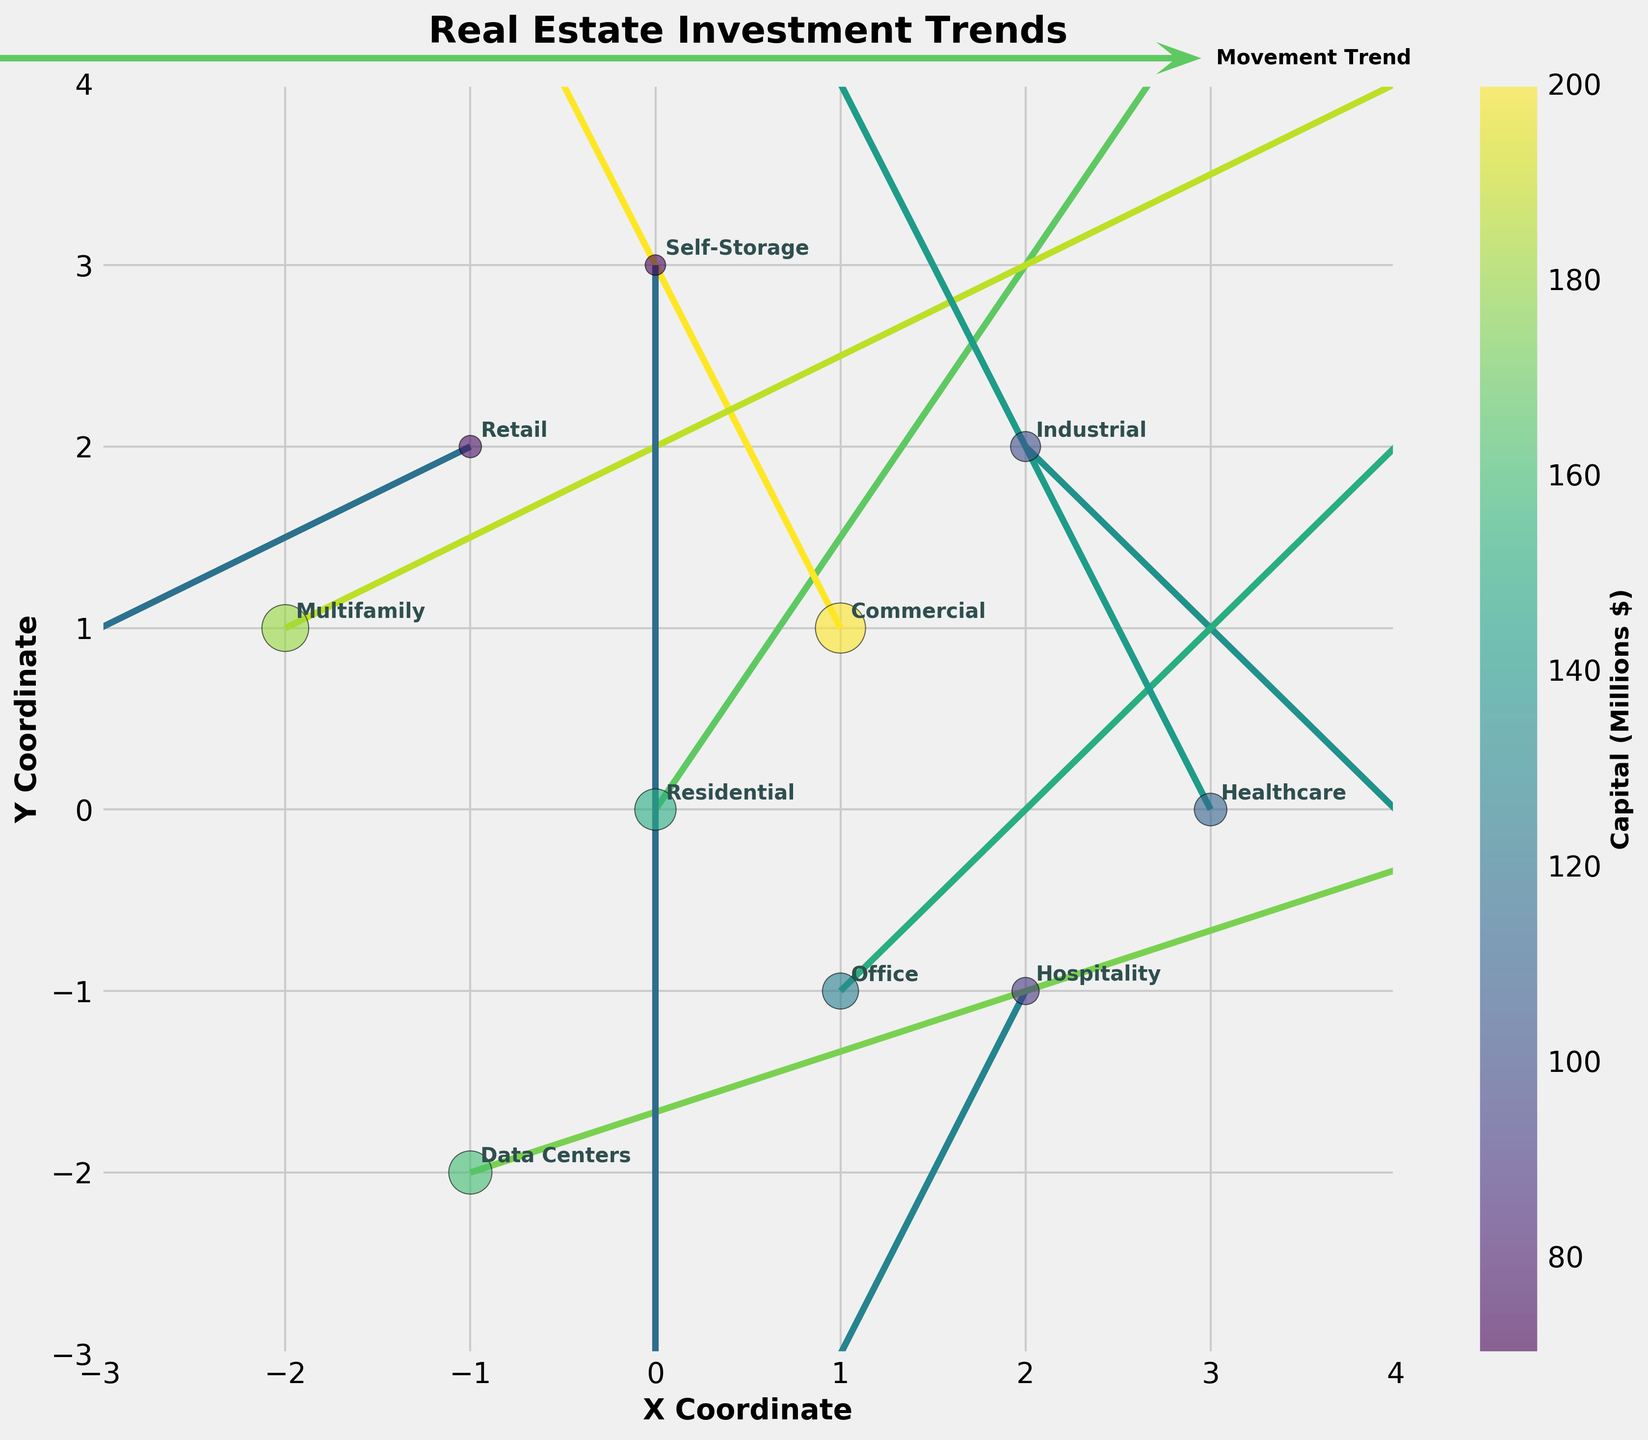What is the title of the plot? The title of the plot is located at the top of the figure. It reads "Real Estate Investment Trends".
Answer: Real Estate Investment Trends Which sector has the largest investment capital? The sector with the largest bubble indicates the greatest investment capital. It is the Commercial sector.
Answer: Commercial What is the X coordinate of the Industrial sector? The Industrial sector is labeled on the plot. Its X coordinate is 2.
Answer: 2 Which sector exhibits a movement vector with a positive X direction and a negative Y direction? To find sectors with a positive X and negative Y direction vector, look at the quiver arrows. The Industrial sector meets this criterion with a vector (1, -1).
Answer: Industrial Which sector has the smallest bubble? The sector with the smallest bubble size, indicating the smallest investment capital, is the Self-Storage sector.
Answer: Self-Storage How many sectors have an overall investment movement trend in the positive Y direction? Count the sectors with vectors pointing upwards. These sectors are Residential, Commercial, Office, and Healthcare, totaling four.
Answer: 4 Which sector has the highest U component in its vector? The U component is the X-direction value of the vector. Data Centers has the highest U component of 3.
Answer: Data Centers Compare the investment capital of Multifamily and Healthcare sectors. Which has more? Look at the size of the bubbles and the colorbar. Multifamily has a capital of 180 million, and Healthcare has 110 million. Multifamily has more.
Answer: Multifamily What are the coordinates of the Retail sector? The Retail sector is labeled on the plot. Its coordinates are (-1, 2).
Answer: (-1, 2) What is the direction of the movement for the Hospitality sector? The direction of the vector for the Hospitality sector can be determined by its U and V components, which are (-1, -2). This corresponds to a movement to the left and downward.
Answer: Left and downward 